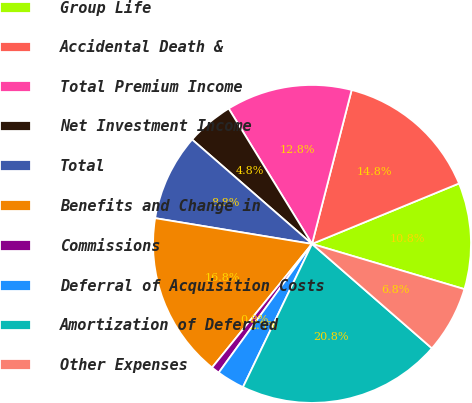Convert chart to OTSL. <chart><loc_0><loc_0><loc_500><loc_500><pie_chart><fcel>Group Life<fcel>Accidental Death &<fcel>Total Premium Income<fcel>Net Investment Income<fcel>Total<fcel>Benefits and Change in<fcel>Commissions<fcel>Deferral of Acquisition Costs<fcel>Amortization of Deferred<fcel>Other Expenses<nl><fcel>10.8%<fcel>14.78%<fcel>12.79%<fcel>4.82%<fcel>8.81%<fcel>16.77%<fcel>0.84%<fcel>2.83%<fcel>20.75%<fcel>6.81%<nl></chart> 